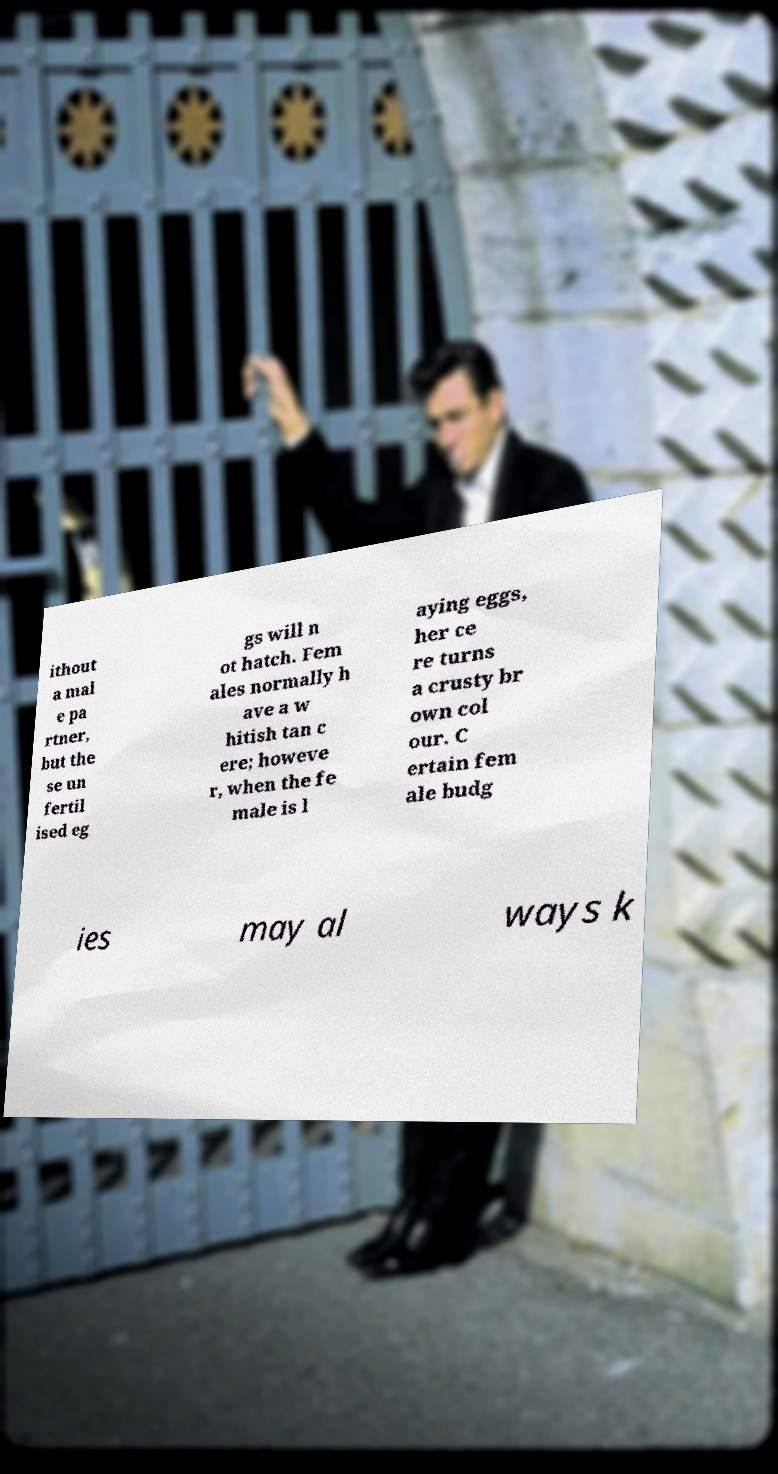There's text embedded in this image that I need extracted. Can you transcribe it verbatim? ithout a mal e pa rtner, but the se un fertil ised eg gs will n ot hatch. Fem ales normally h ave a w hitish tan c ere; howeve r, when the fe male is l aying eggs, her ce re turns a crusty br own col our. C ertain fem ale budg ies may al ways k 